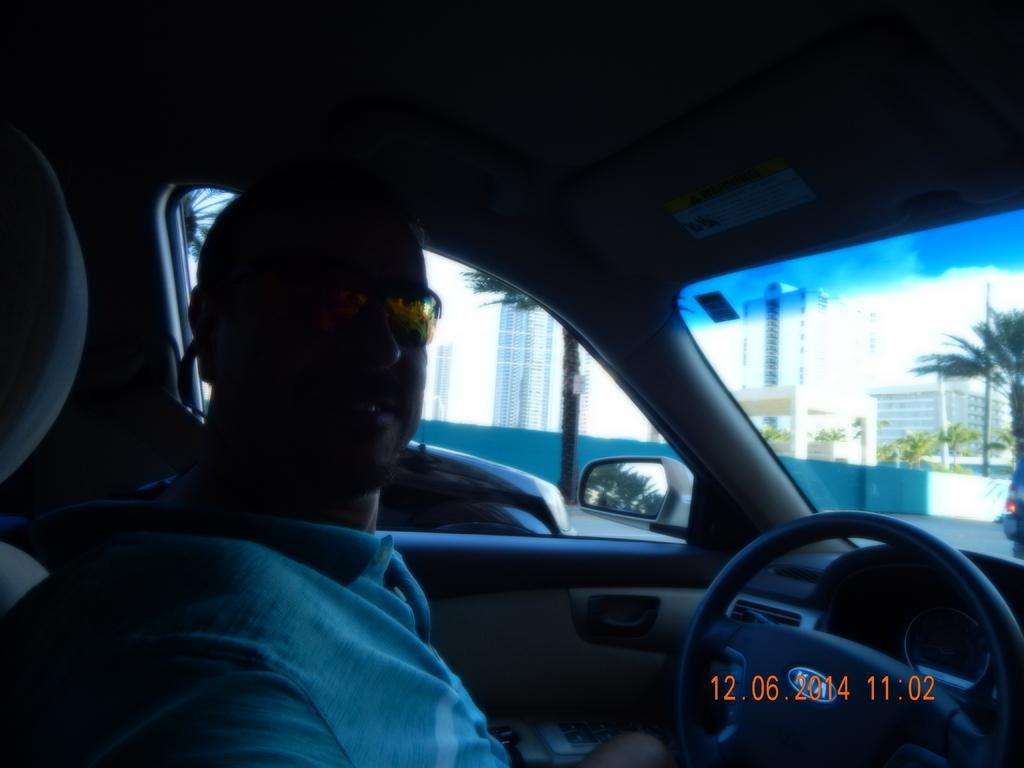Please provide a concise description of this image. In the image there is a man sat on a car and outside the car there are buildings on the left side and in the front,it seems to be on road. 